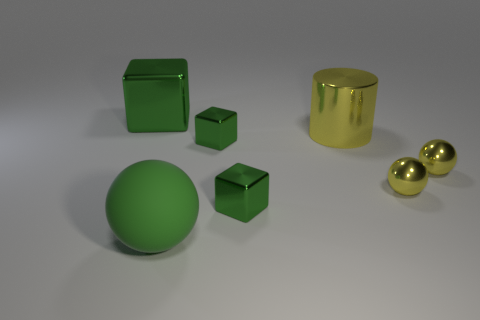There is a green thing that is on the left side of the big thing in front of the large metal thing in front of the big block; what size is it?
Your response must be concise. Large. Are there fewer matte balls behind the large ball than large green rubber objects left of the yellow metal cylinder?
Your answer should be compact. Yes. How many green objects have the same material as the large yellow object?
Your answer should be compact. 3. Is there a sphere to the right of the big green thing right of the green metal thing to the left of the large rubber object?
Keep it short and to the point. Yes. There is a big green object that is the same material as the cylinder; what shape is it?
Your response must be concise. Cube. Are there more big yellow metallic objects than brown cylinders?
Provide a succinct answer. Yes. There is a large yellow shiny object; is it the same shape as the big thing behind the metal cylinder?
Keep it short and to the point. No. What is the material of the green sphere?
Ensure brevity in your answer.  Rubber. What color is the big metallic object right of the big block behind the ball left of the big cylinder?
Your answer should be compact. Yellow. How many metallic cylinders are the same size as the rubber thing?
Your answer should be compact. 1. 